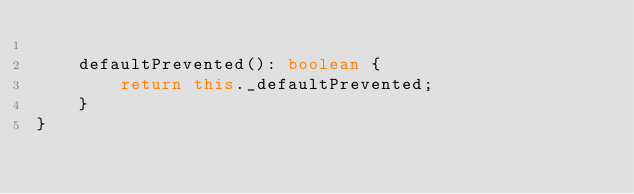<code> <loc_0><loc_0><loc_500><loc_500><_TypeScript_>
    defaultPrevented(): boolean {
        return this._defaultPrevented;
    }
}</code> 